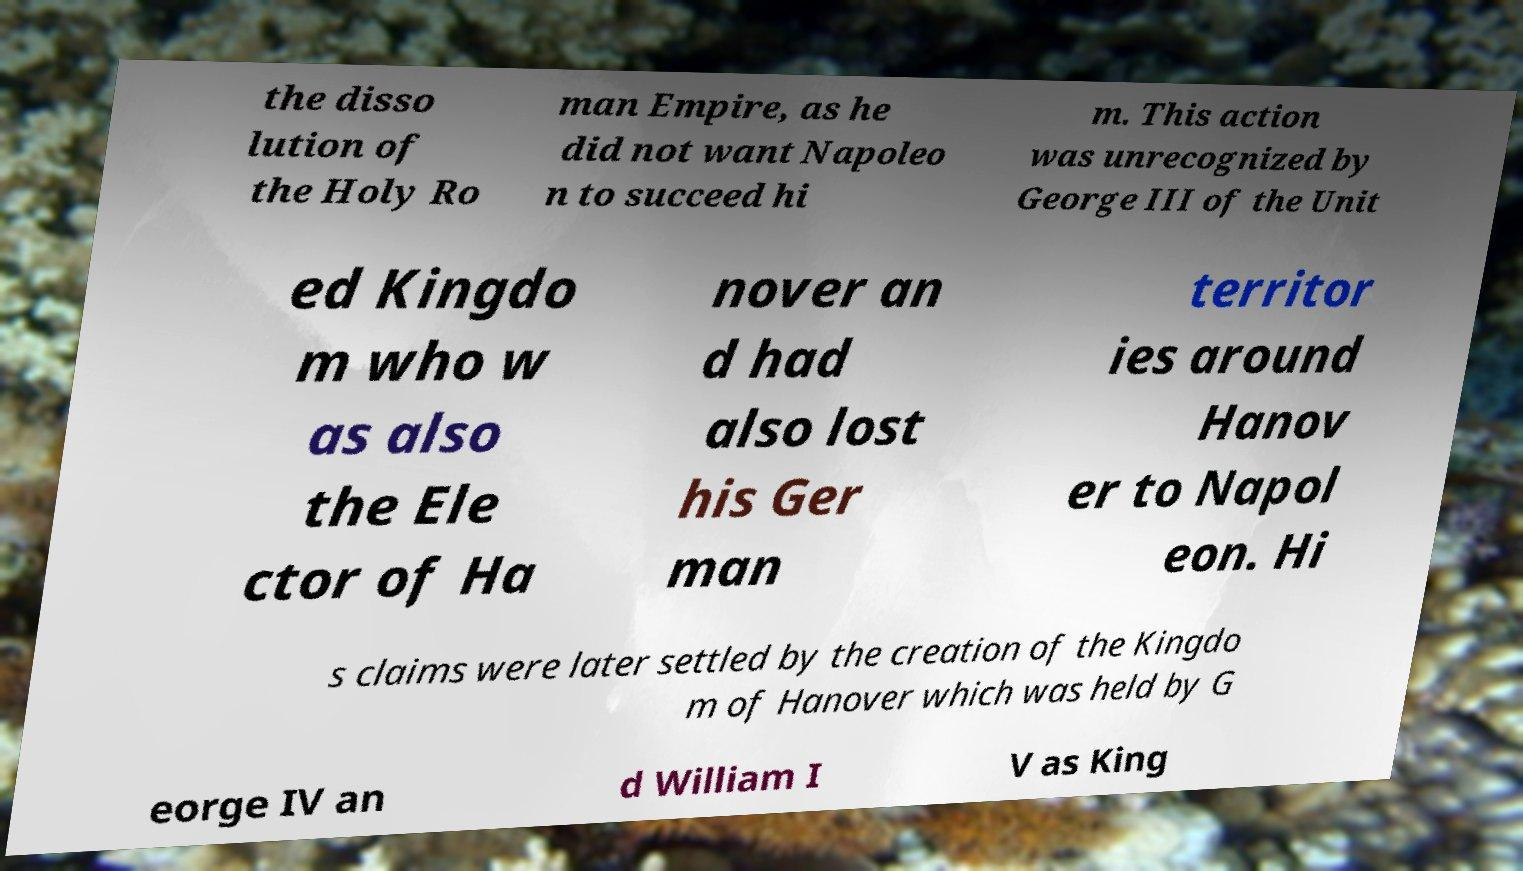Please read and relay the text visible in this image. What does it say? the disso lution of the Holy Ro man Empire, as he did not want Napoleo n to succeed hi m. This action was unrecognized by George III of the Unit ed Kingdo m who w as also the Ele ctor of Ha nover an d had also lost his Ger man territor ies around Hanov er to Napol eon. Hi s claims were later settled by the creation of the Kingdo m of Hanover which was held by G eorge IV an d William I V as King 